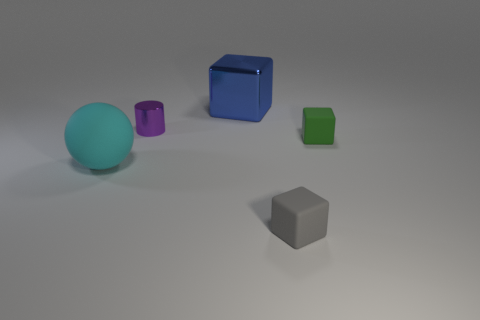Is the number of green metallic blocks greater than the number of small green cubes?
Give a very brief answer. No. What is the large cyan sphere made of?
Offer a terse response. Rubber. Is the size of the cube behind the green cube the same as the cyan ball?
Keep it short and to the point. Yes. There is a thing that is behind the tiny purple metallic cylinder; what is its size?
Provide a succinct answer. Large. How many tiny objects are there?
Provide a short and direct response. 3. Is the tiny metallic object the same color as the large metallic thing?
Make the answer very short. No. There is a rubber thing that is on the right side of the small cylinder and in front of the green block; what color is it?
Your answer should be compact. Gray. There is a tiny green rubber block; are there any large spheres right of it?
Provide a succinct answer. No. What number of small matte cubes are behind the big thing in front of the green thing?
Ensure brevity in your answer.  1. What size is the block that is the same material as the tiny purple cylinder?
Make the answer very short. Large. 